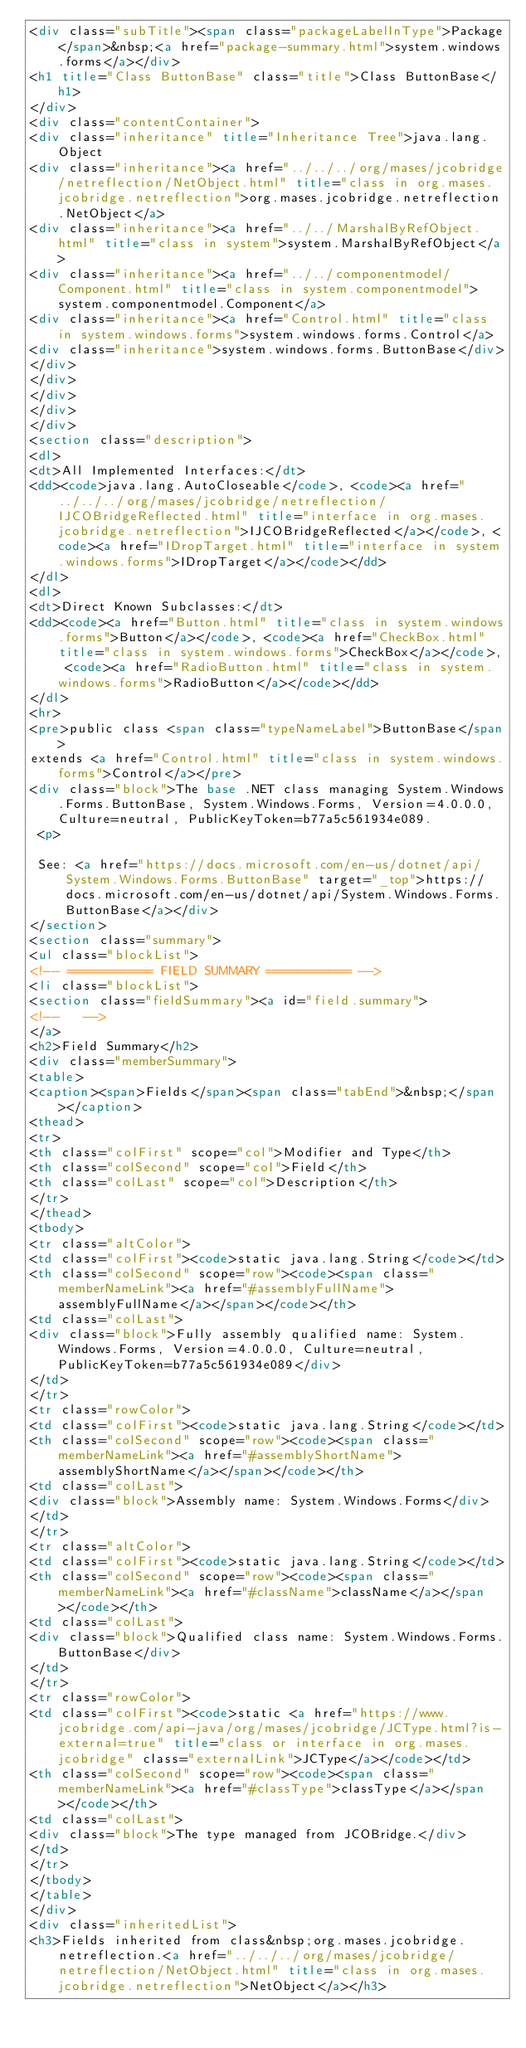Convert code to text. <code><loc_0><loc_0><loc_500><loc_500><_HTML_><div class="subTitle"><span class="packageLabelInType">Package</span>&nbsp;<a href="package-summary.html">system.windows.forms</a></div>
<h1 title="Class ButtonBase" class="title">Class ButtonBase</h1>
</div>
<div class="contentContainer">
<div class="inheritance" title="Inheritance Tree">java.lang.Object
<div class="inheritance"><a href="../../../org/mases/jcobridge/netreflection/NetObject.html" title="class in org.mases.jcobridge.netreflection">org.mases.jcobridge.netreflection.NetObject</a>
<div class="inheritance"><a href="../../MarshalByRefObject.html" title="class in system">system.MarshalByRefObject</a>
<div class="inheritance"><a href="../../componentmodel/Component.html" title="class in system.componentmodel">system.componentmodel.Component</a>
<div class="inheritance"><a href="Control.html" title="class in system.windows.forms">system.windows.forms.Control</a>
<div class="inheritance">system.windows.forms.ButtonBase</div>
</div>
</div>
</div>
</div>
</div>
<section class="description">
<dl>
<dt>All Implemented Interfaces:</dt>
<dd><code>java.lang.AutoCloseable</code>, <code><a href="../../../org/mases/jcobridge/netreflection/IJCOBridgeReflected.html" title="interface in org.mases.jcobridge.netreflection">IJCOBridgeReflected</a></code>, <code><a href="IDropTarget.html" title="interface in system.windows.forms">IDropTarget</a></code></dd>
</dl>
<dl>
<dt>Direct Known Subclasses:</dt>
<dd><code><a href="Button.html" title="class in system.windows.forms">Button</a></code>, <code><a href="CheckBox.html" title="class in system.windows.forms">CheckBox</a></code>, <code><a href="RadioButton.html" title="class in system.windows.forms">RadioButton</a></code></dd>
</dl>
<hr>
<pre>public class <span class="typeNameLabel">ButtonBase</span>
extends <a href="Control.html" title="class in system.windows.forms">Control</a></pre>
<div class="block">The base .NET class managing System.Windows.Forms.ButtonBase, System.Windows.Forms, Version=4.0.0.0, Culture=neutral, PublicKeyToken=b77a5c561934e089.
 <p>
 
 See: <a href="https://docs.microsoft.com/en-us/dotnet/api/System.Windows.Forms.ButtonBase" target="_top">https://docs.microsoft.com/en-us/dotnet/api/System.Windows.Forms.ButtonBase</a></div>
</section>
<section class="summary">
<ul class="blockList">
<!-- =========== FIELD SUMMARY =========== -->
<li class="blockList">
<section class="fieldSummary"><a id="field.summary">
<!--   -->
</a>
<h2>Field Summary</h2>
<div class="memberSummary">
<table>
<caption><span>Fields</span><span class="tabEnd">&nbsp;</span></caption>
<thead>
<tr>
<th class="colFirst" scope="col">Modifier and Type</th>
<th class="colSecond" scope="col">Field</th>
<th class="colLast" scope="col">Description</th>
</tr>
</thead>
<tbody>
<tr class="altColor">
<td class="colFirst"><code>static java.lang.String</code></td>
<th class="colSecond" scope="row"><code><span class="memberNameLink"><a href="#assemblyFullName">assemblyFullName</a></span></code></th>
<td class="colLast">
<div class="block">Fully assembly qualified name: System.Windows.Forms, Version=4.0.0.0, Culture=neutral, PublicKeyToken=b77a5c561934e089</div>
</td>
</tr>
<tr class="rowColor">
<td class="colFirst"><code>static java.lang.String</code></td>
<th class="colSecond" scope="row"><code><span class="memberNameLink"><a href="#assemblyShortName">assemblyShortName</a></span></code></th>
<td class="colLast">
<div class="block">Assembly name: System.Windows.Forms</div>
</td>
</tr>
<tr class="altColor">
<td class="colFirst"><code>static java.lang.String</code></td>
<th class="colSecond" scope="row"><code><span class="memberNameLink"><a href="#className">className</a></span></code></th>
<td class="colLast">
<div class="block">Qualified class name: System.Windows.Forms.ButtonBase</div>
</td>
</tr>
<tr class="rowColor">
<td class="colFirst"><code>static <a href="https://www.jcobridge.com/api-java/org/mases/jcobridge/JCType.html?is-external=true" title="class or interface in org.mases.jcobridge" class="externalLink">JCType</a></code></td>
<th class="colSecond" scope="row"><code><span class="memberNameLink"><a href="#classType">classType</a></span></code></th>
<td class="colLast">
<div class="block">The type managed from JCOBridge.</div>
</td>
</tr>
</tbody>
</table>
</div>
<div class="inheritedList">
<h3>Fields inherited from class&nbsp;org.mases.jcobridge.netreflection.<a href="../../../org/mases/jcobridge/netreflection/NetObject.html" title="class in org.mases.jcobridge.netreflection">NetObject</a></h3></code> 